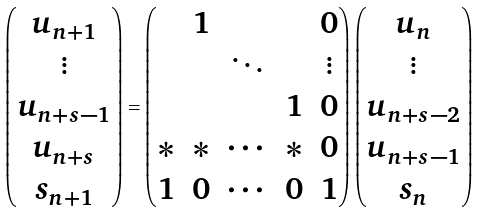Convert formula to latex. <formula><loc_0><loc_0><loc_500><loc_500>\begin{pmatrix} u _ { n + 1 } \\ \vdots \\ u _ { n + s - 1 } \\ u _ { n + s } \\ s _ { n + 1 } \end{pmatrix} = \begin{pmatrix} & 1 & & & 0 \\ & & \ddots & & \vdots \\ & & & 1 & 0 \\ \ast & \ast & \cdots & \ast & 0 \\ 1 & 0 & \cdots & 0 & 1 \end{pmatrix} \begin{pmatrix} u _ { n } \\ \vdots \\ u _ { n + s - 2 } \\ u _ { n + s - 1 } \\ s _ { n } \end{pmatrix}</formula> 